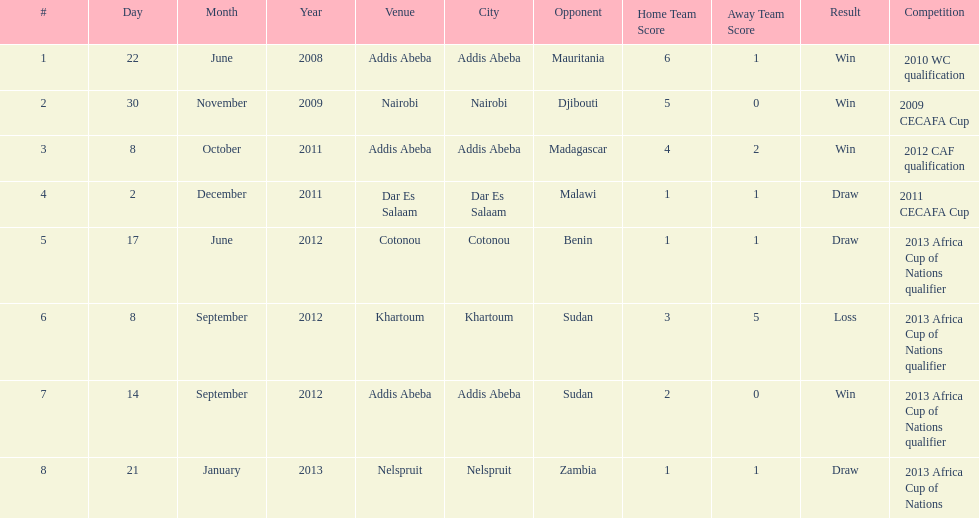How long in years down this table cover? 5. 